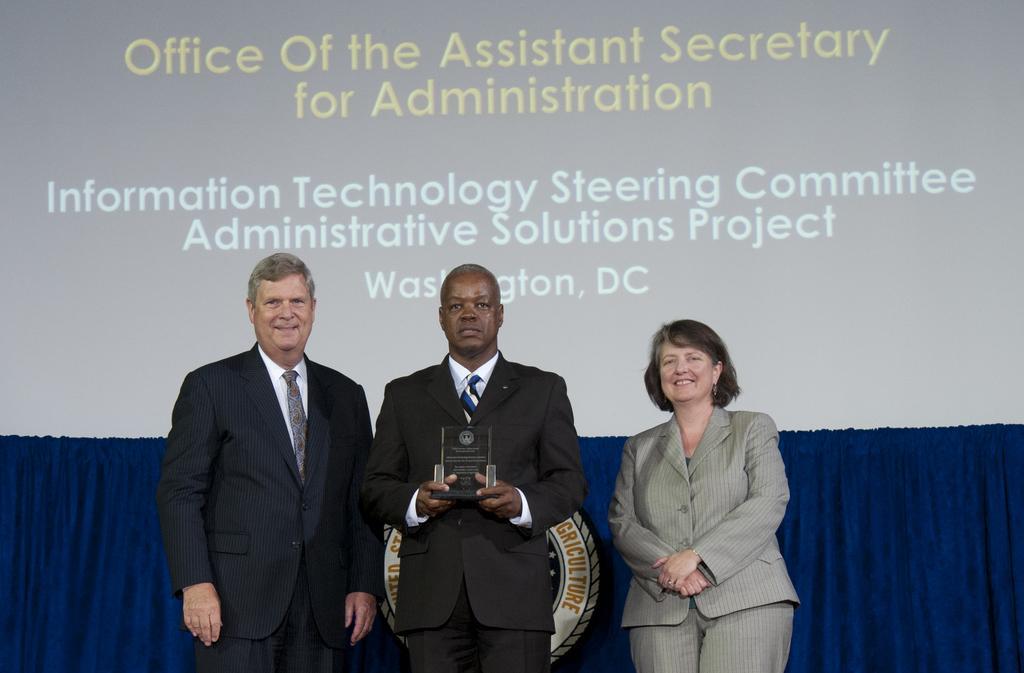Can you describe this image briefly? In this image we can see two men and a woman standing. In that a man is holding a memento. On the backside we can see a curtain and a display screen containing some text on it. 